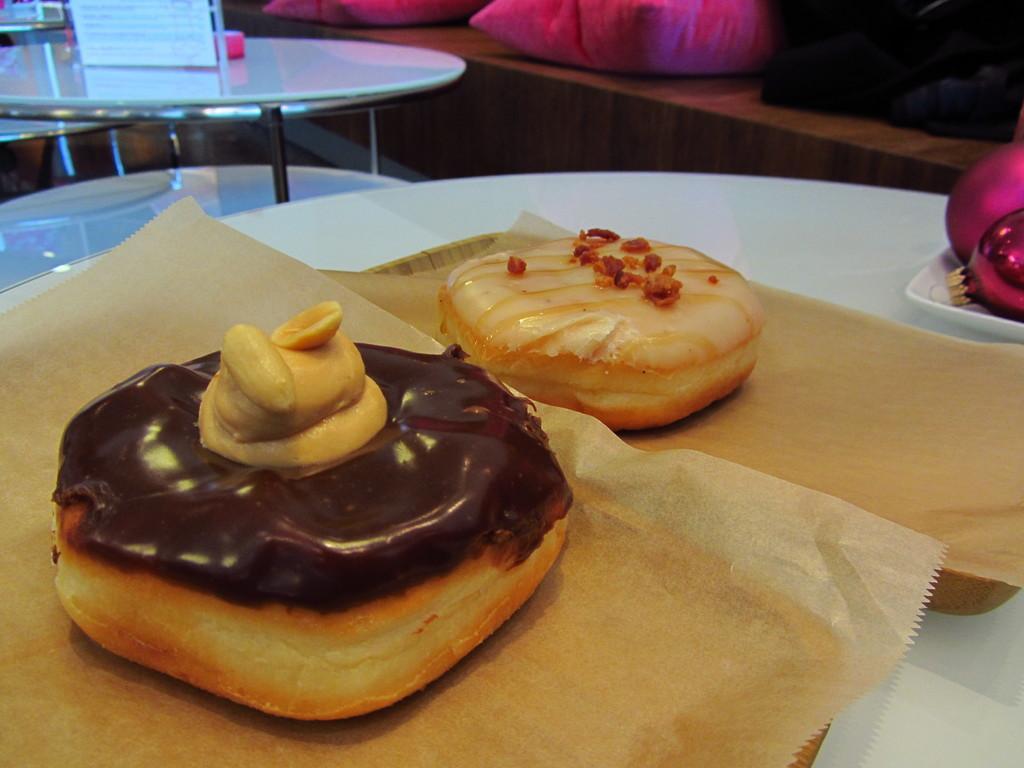How would you summarize this image in a sentence or two? In this picture there is food on the covers and there are objects on the plate and there is a plate and tray on the table. At the back there is a board on the table and there is a chair and there are pillows on the wooden object. 